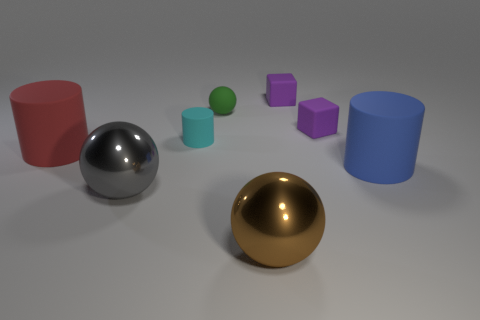What is the shape of the cyan matte thing? The shape of the cyan matte object is a cylinder. It's one of several geometric shapes visible in the image, which includes a variety of colors and surfaces. 